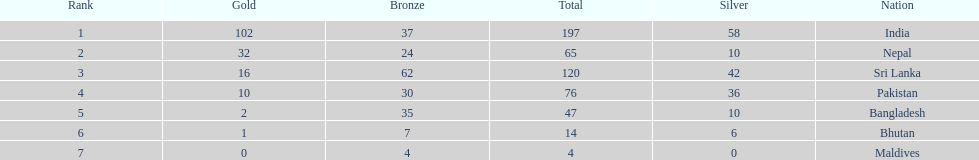Write the full table. {'header': ['Rank', 'Gold', 'Bronze', 'Total', 'Silver', 'Nation'], 'rows': [['1', '102', '37', '197', '58', 'India'], ['2', '32', '24', '65', '10', 'Nepal'], ['3', '16', '62', '120', '42', 'Sri Lanka'], ['4', '10', '30', '76', '36', 'Pakistan'], ['5', '2', '35', '47', '10', 'Bangladesh'], ['6', '1', '7', '14', '6', 'Bhutan'], ['7', '0', '4', '4', '0', 'Maldives']]} What is the difference between the nation with the most medals and the nation with the least amount of medals? 193. 